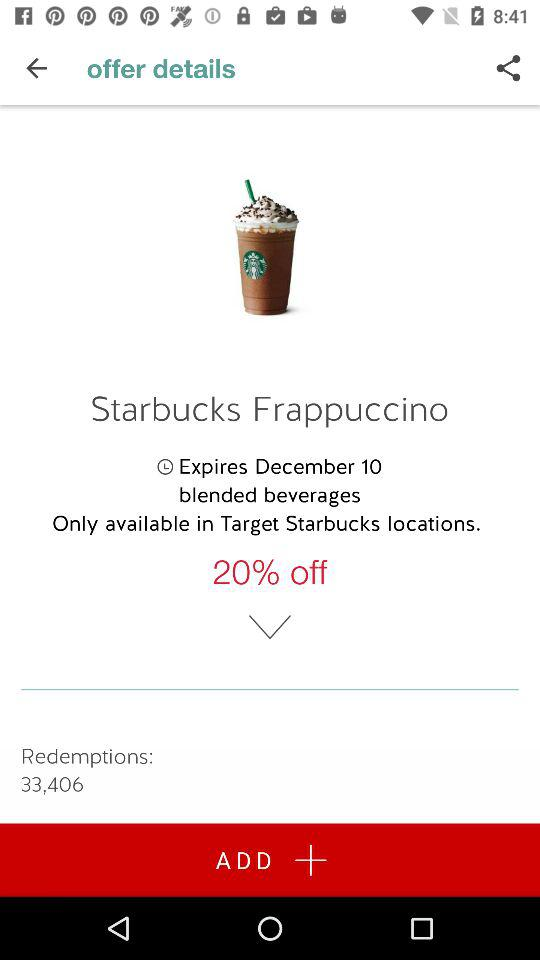What are the redemption points for "Starbucks Frappuccino"? The redemption points are 33,406. 